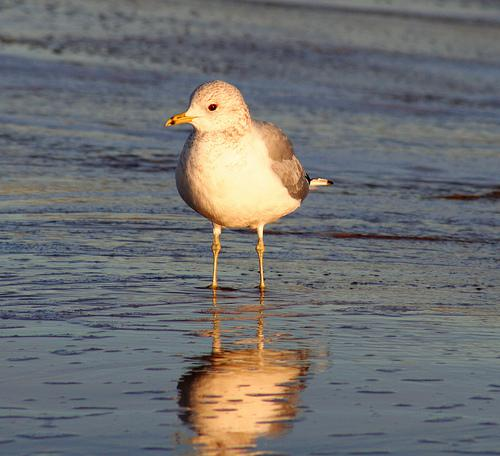Question: why is this bird standing around?
Choices:
A. Waiting for food.
B. Waiting on something to catch.
C. Waiting for water.
D. Nothing to do.
Answer with the letter. Answer: B Question: when will the bird eat?
Choices:
A. Soon.
B. At noontime.
C. When he sees food.
D. When he is hungry.
Answer with the letter. Answer: C Question: who else is in the photo with the bird?
Choices:
A. Other birds.
B. A man.
C. No one.
D. A cat.
Answer with the letter. Answer: C 